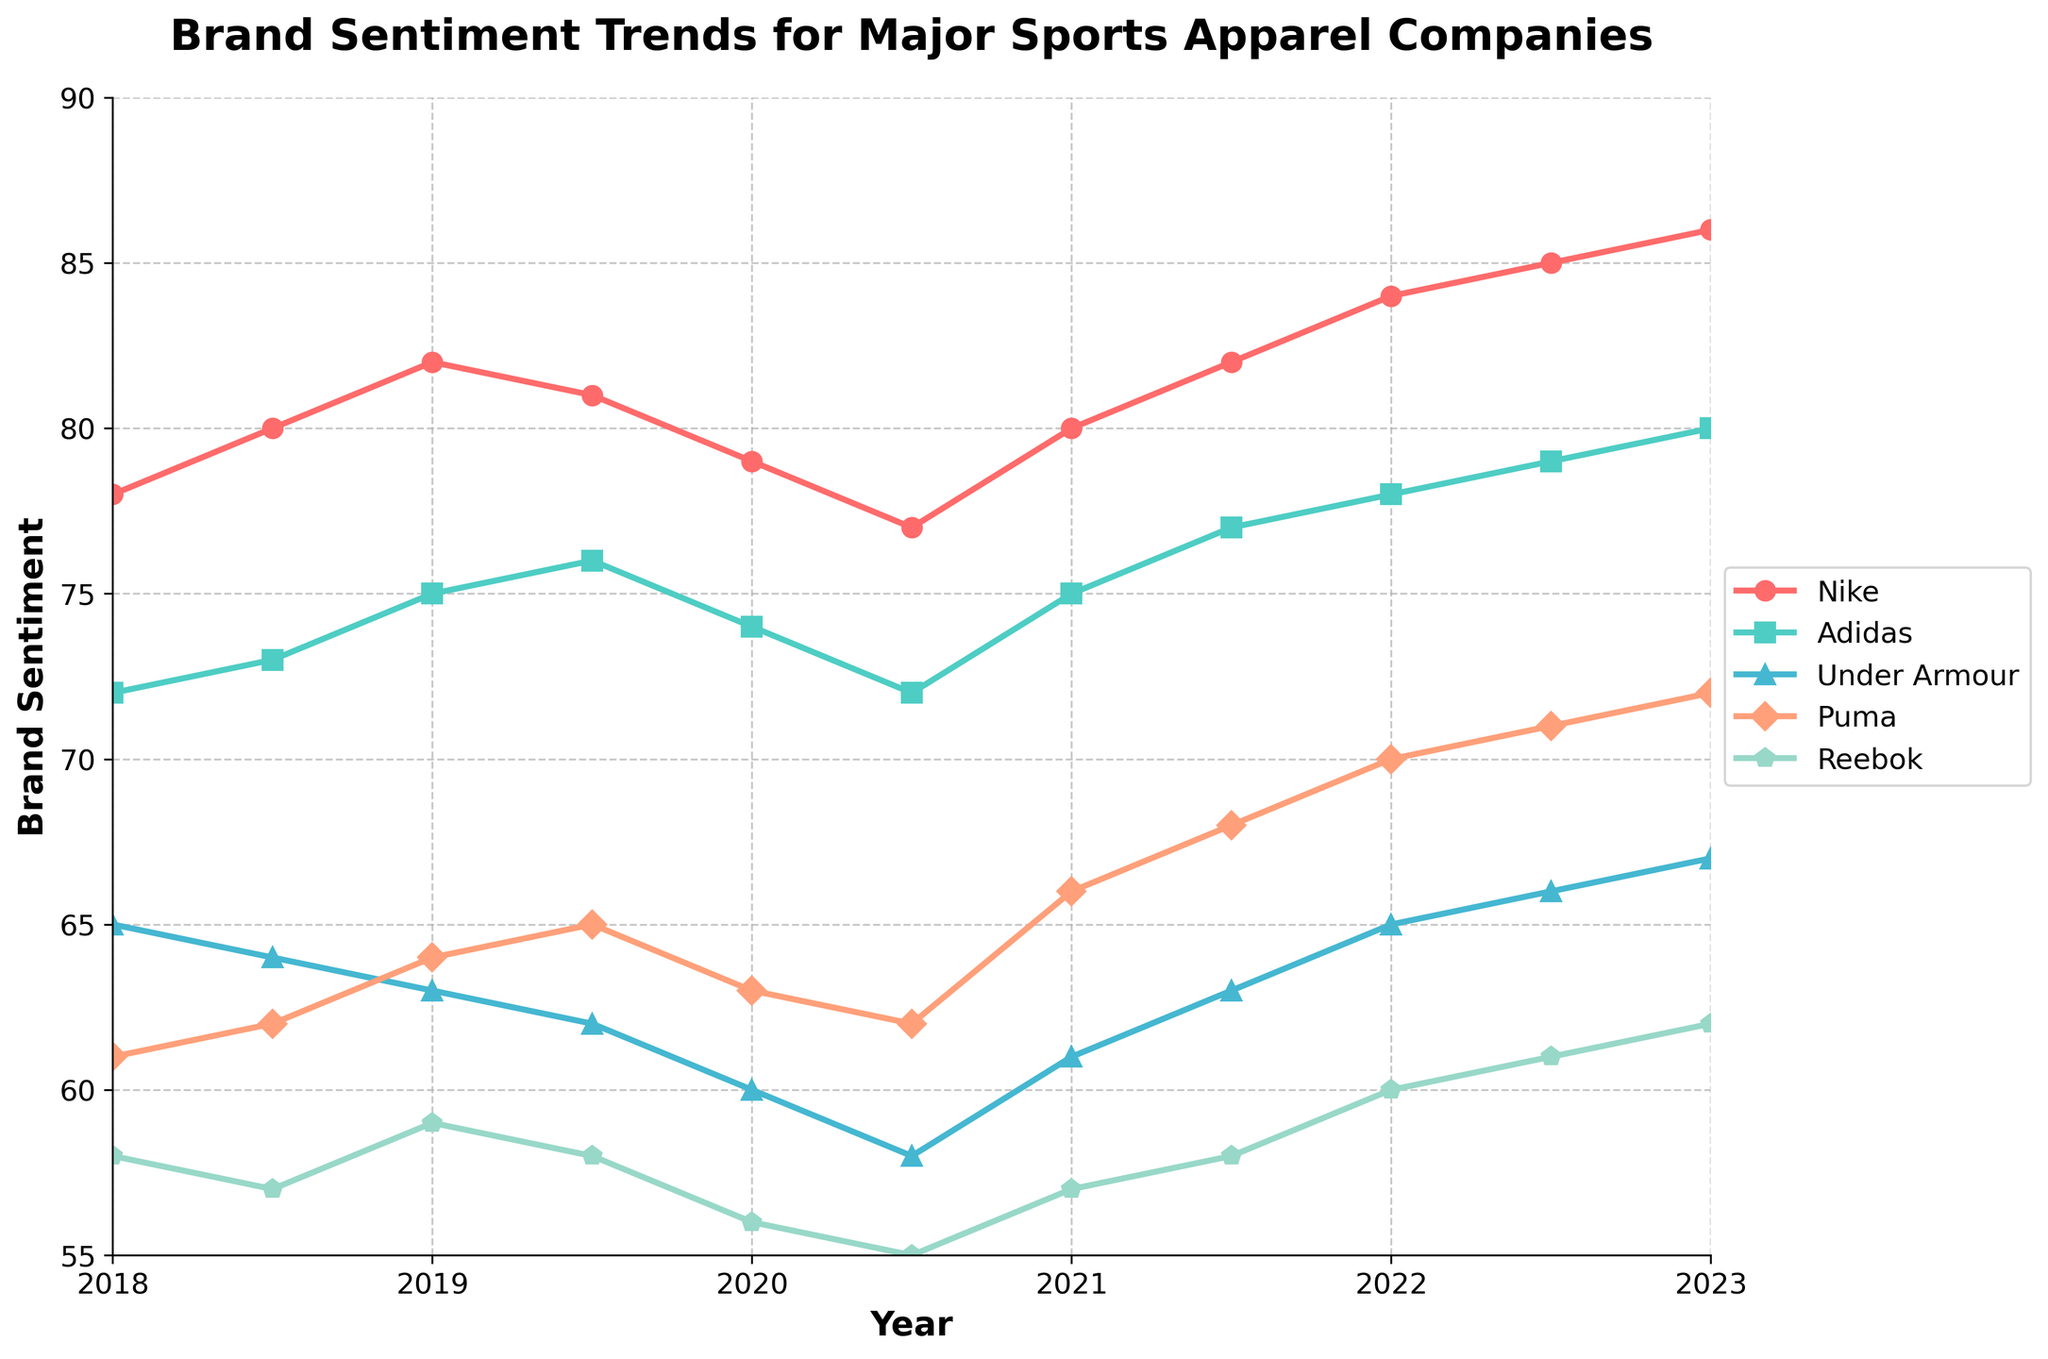Which brand showed the highest sentiment in 2023? Look at the end of the chart for 2023. Nike has the highest sentiment score at 86.
Answer: Nike From 2018 to 2023, which brand had the most significant overall increase in sentiment score? Calculate the difference between the 2023 and 2018 sentiment scores for each brand. Nike increased from 78 to 86 (8 points), Adidas from 72 to 80 (8 points), Under Armour from 65 to 67 (2 points), Puma from 61 to 72 (11 points), and Reebok from 58 to 62 (4 points). Puma had the largest increase.
Answer: Puma What is the average sentiment score of Adidas over the 5-year period? Sum the sentiment scores of Adidas from 2018 to 2023: (72 + 73 + 75 + 76 + 74 + 72 + 75 + 77 + 78 + 79 + 80) = 851. Divide by the number of data points (11) to get the average: 851/11 ≈ 77.36.
Answer: 77.36 Which brand showed a decreasing trend between 2019.5 and 2020.5? Look at the chart and identify trends between 2019.5 and 2020.5. Nike's sentiment score decreased from 81 to 77, showing a decreasing trend.
Answer: Nike Did any brand have a lower sentiment score in 2022 compared to 2018? Compare sentiment scores of 2022 and 2018. Only Reebok had a lower sentiment score in 2022 (60) compared to 2018 (58).
Answer: No, only Reebok stayed similar How did Under Armour's sentiment score change from mid-2021 to mid-2022? Look at the chart for Under Armour's sentiment score between these periods. It increased from 63 to 66.
Answer: Increased by 3 Which brand showed the most fluctuating trend over the years? Check the graph for the most ups and downs in the sentiment score. Nike has the most fluctuations, peaking and dropping several times.
Answer: Nike What's the median sentiment score for Puma from 2018 to 2023? List Puma's sentiment scores from 2018 to 2023: [61, 62, 64, 65, 63, 62, 66, 68, 70, 71, 72]. Since there are 11 scores, the median is the 6th value when sorted: 64.
Answer: 64 Is the overall trend of Reebok's sentiment score increasing, decreasing, or stable from 2018 to 2023? Look at Reebok's scores from 2018 (58) to 2023 (62). There is a slight increase but not substantial, suggesting stability.
Answer: Stable Compare the sentiment score trends of Nike and Adidas between 2021.5 and 2023. Look at the chart for Nike and Adidas from 2021.5 and 2023. Both brands show an increasing trend, with Adidas going from 77 to 80 and Nike from 82 to 86.
Answer: Both increasing 